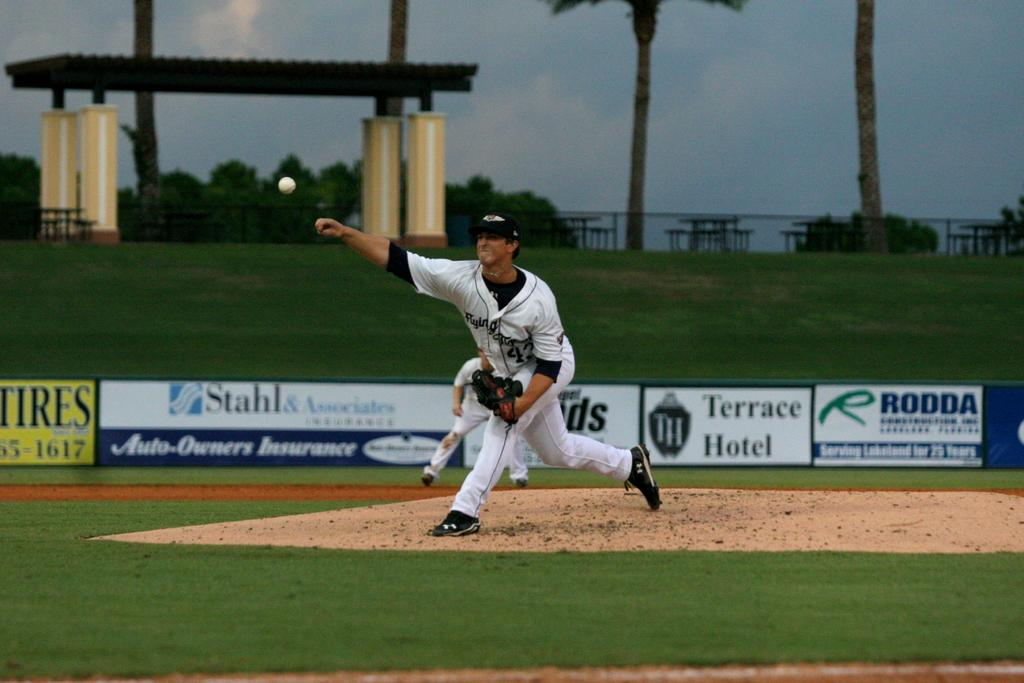<image>
Describe the image concisely. A baseball pitcher wearing a Flying J's uniform throws a pitch. 